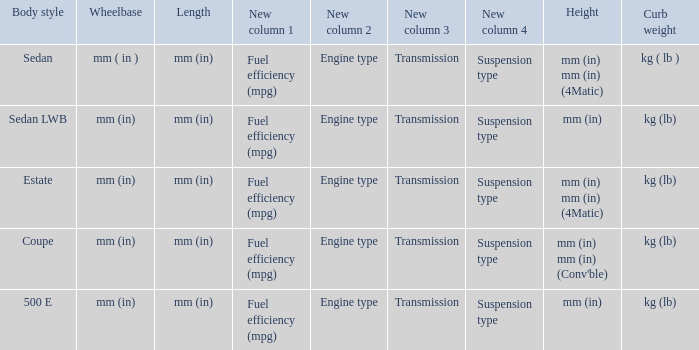What's the length of the model with Sedan body style? Mm (in). 